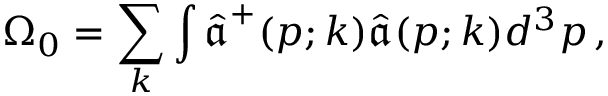<formula> <loc_0><loc_0><loc_500><loc_500>\Omega _ { 0 } = \sum _ { k } \int \hat { \mathfrak a } ^ { + } ( p ; k ) \hat { \mathfrak a } ( p ; k ) d ^ { 3 } p \, ,</formula> 